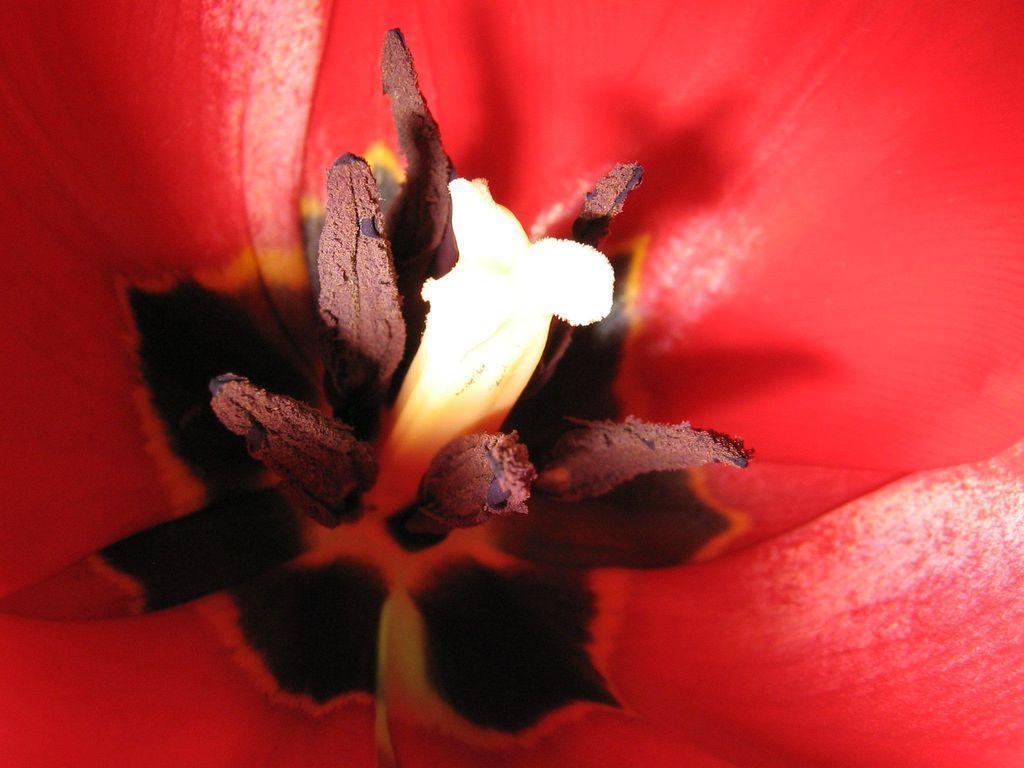Describe this image in one or two sentences. Here in this picture we can see a closeup view of a flower and we can also see its pollen grains. 